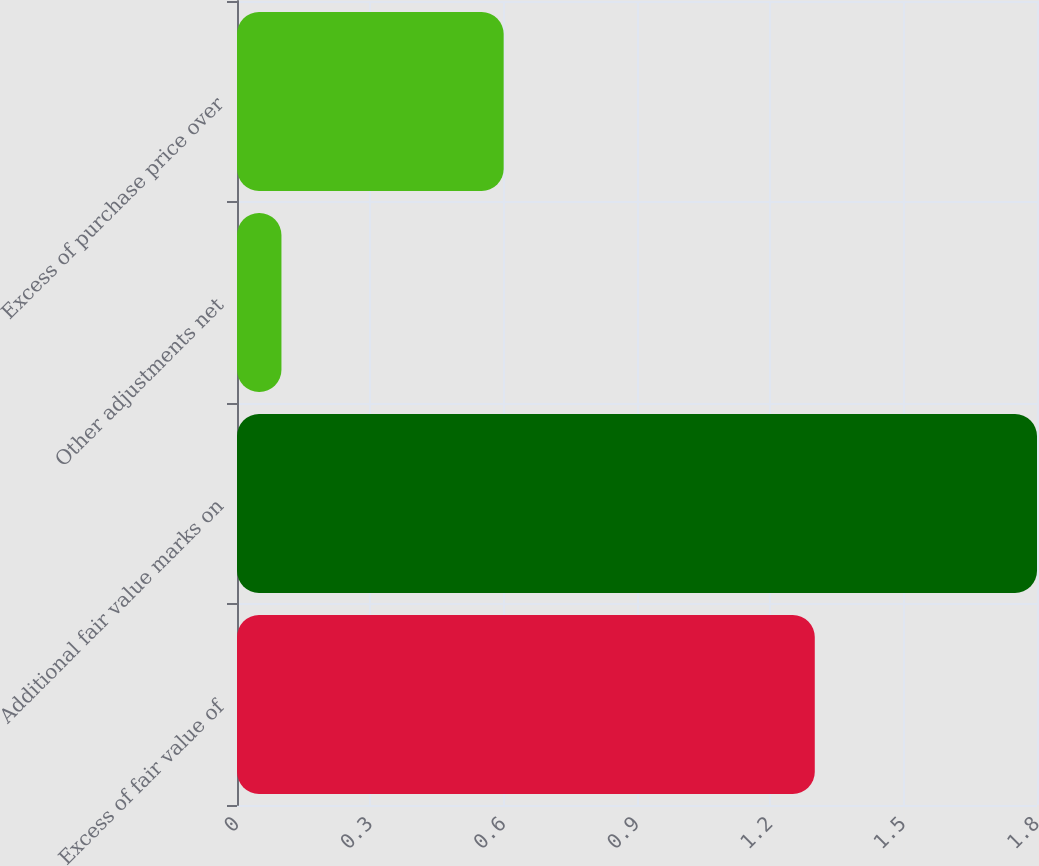<chart> <loc_0><loc_0><loc_500><loc_500><bar_chart><fcel>Excess of fair value of<fcel>Additional fair value marks on<fcel>Other adjustments net<fcel>Excess of purchase price over<nl><fcel>1.3<fcel>1.8<fcel>0.1<fcel>0.6<nl></chart> 